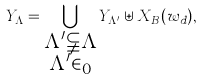Convert formula to latex. <formula><loc_0><loc_0><loc_500><loc_500>Y _ { \Lambda } = \bigcup _ { \substack { \Lambda ^ { \prime } \subsetneqq \Lambda \\ \Lambda ^ { \prime } \in \L _ { 0 } } } Y _ { \Lambda ^ { \prime } } \uplus X _ { B } ( w _ { d } ) ,</formula> 